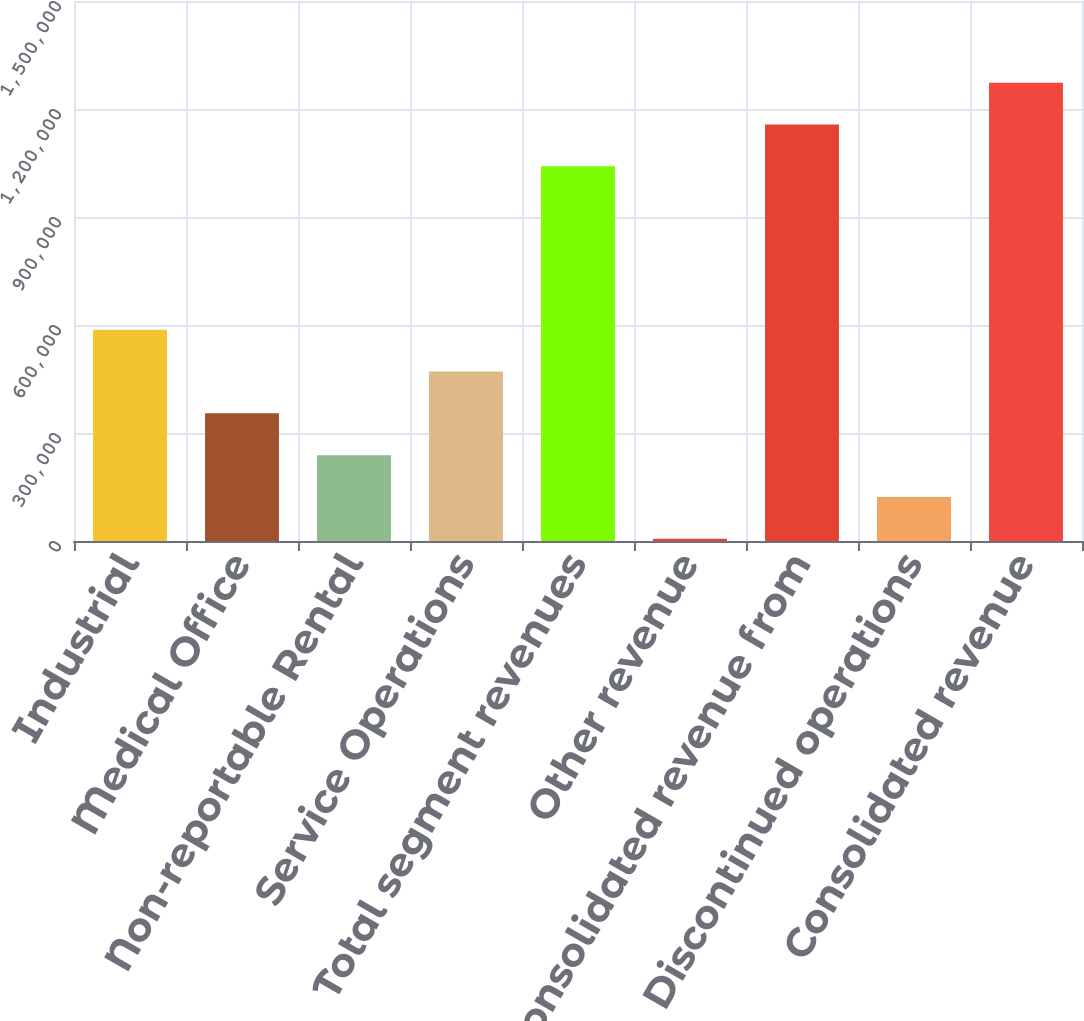Convert chart to OTSL. <chart><loc_0><loc_0><loc_500><loc_500><bar_chart><fcel>Industrial<fcel>Medical Office<fcel>Non-reportable Rental<fcel>Service Operations<fcel>Total segment revenues<fcel>Other revenue<fcel>Consolidated revenue from<fcel>Discontinued operations<fcel>Consolidated revenue<nl><fcel>586938<fcel>354619<fcel>238460<fcel>470779<fcel>1.04071e+06<fcel>6141<fcel>1.15687e+06<fcel>122300<fcel>1.27303e+06<nl></chart> 